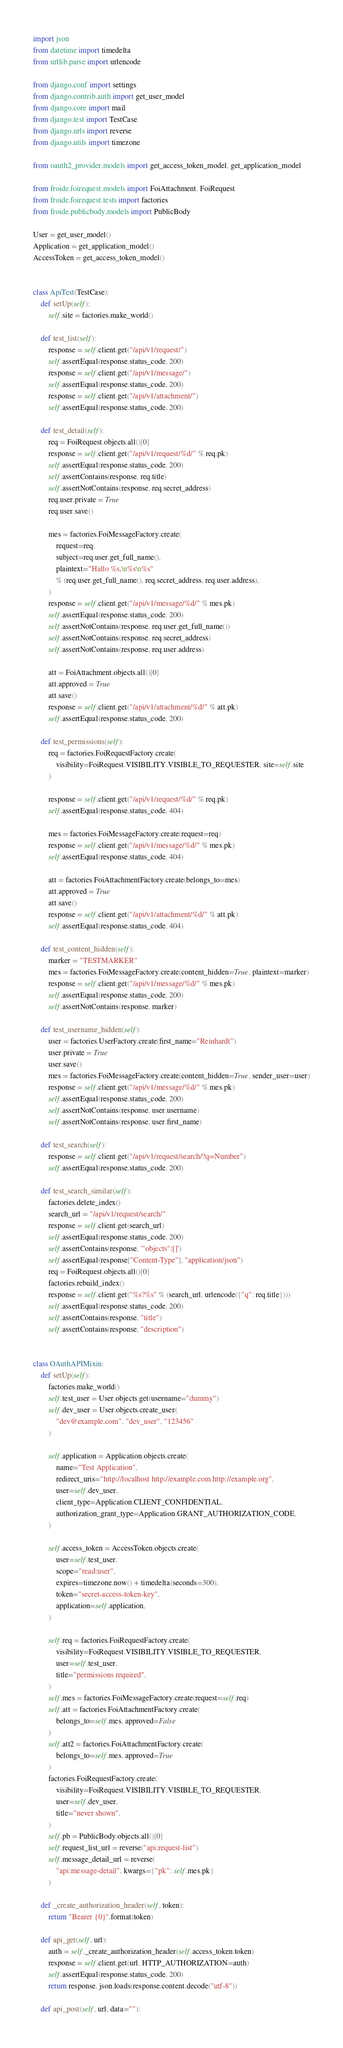Convert code to text. <code><loc_0><loc_0><loc_500><loc_500><_Python_>import json
from datetime import timedelta
from urllib.parse import urlencode

from django.conf import settings
from django.contrib.auth import get_user_model
from django.core import mail
from django.test import TestCase
from django.urls import reverse
from django.utils import timezone

from oauth2_provider.models import get_access_token_model, get_application_model

from froide.foirequest.models import FoiAttachment, FoiRequest
from froide.foirequest.tests import factories
from froide.publicbody.models import PublicBody

User = get_user_model()
Application = get_application_model()
AccessToken = get_access_token_model()


class ApiTest(TestCase):
    def setUp(self):
        self.site = factories.make_world()

    def test_list(self):
        response = self.client.get("/api/v1/request/")
        self.assertEqual(response.status_code, 200)
        response = self.client.get("/api/v1/message/")
        self.assertEqual(response.status_code, 200)
        response = self.client.get("/api/v1/attachment/")
        self.assertEqual(response.status_code, 200)

    def test_detail(self):
        req = FoiRequest.objects.all()[0]
        response = self.client.get("/api/v1/request/%d/" % req.pk)
        self.assertEqual(response.status_code, 200)
        self.assertContains(response, req.title)
        self.assertNotContains(response, req.secret_address)
        req.user.private = True
        req.user.save()

        mes = factories.FoiMessageFactory.create(
            request=req,
            subject=req.user.get_full_name(),
            plaintext="Hallo %s,\n%s\n%s"
            % (req.user.get_full_name(), req.secret_address, req.user.address),
        )
        response = self.client.get("/api/v1/message/%d/" % mes.pk)
        self.assertEqual(response.status_code, 200)
        self.assertNotContains(response, req.user.get_full_name())
        self.assertNotContains(response, req.secret_address)
        self.assertNotContains(response, req.user.address)

        att = FoiAttachment.objects.all()[0]
        att.approved = True
        att.save()
        response = self.client.get("/api/v1/attachment/%d/" % att.pk)
        self.assertEqual(response.status_code, 200)

    def test_permissions(self):
        req = factories.FoiRequestFactory.create(
            visibility=FoiRequest.VISIBILITY.VISIBLE_TO_REQUESTER, site=self.site
        )

        response = self.client.get("/api/v1/request/%d/" % req.pk)
        self.assertEqual(response.status_code, 404)

        mes = factories.FoiMessageFactory.create(request=req)
        response = self.client.get("/api/v1/message/%d/" % mes.pk)
        self.assertEqual(response.status_code, 404)

        att = factories.FoiAttachmentFactory.create(belongs_to=mes)
        att.approved = True
        att.save()
        response = self.client.get("/api/v1/attachment/%d/" % att.pk)
        self.assertEqual(response.status_code, 404)

    def test_content_hidden(self):
        marker = "TESTMARKER"
        mes = factories.FoiMessageFactory.create(content_hidden=True, plaintext=marker)
        response = self.client.get("/api/v1/message/%d/" % mes.pk)
        self.assertEqual(response.status_code, 200)
        self.assertNotContains(response, marker)

    def test_username_hidden(self):
        user = factories.UserFactory.create(first_name="Reinhardt")
        user.private = True
        user.save()
        mes = factories.FoiMessageFactory.create(content_hidden=True, sender_user=user)
        response = self.client.get("/api/v1/message/%d/" % mes.pk)
        self.assertEqual(response.status_code, 200)
        self.assertNotContains(response, user.username)
        self.assertNotContains(response, user.first_name)

    def test_search(self):
        response = self.client.get("/api/v1/request/search/?q=Number")
        self.assertEqual(response.status_code, 200)

    def test_search_similar(self):
        factories.delete_index()
        search_url = "/api/v1/request/search/"
        response = self.client.get(search_url)
        self.assertEqual(response.status_code, 200)
        self.assertContains(response, '"objects":[]')
        self.assertEqual(response["Content-Type"], "application/json")
        req = FoiRequest.objects.all()[0]
        factories.rebuild_index()
        response = self.client.get("%s?%s" % (search_url, urlencode({"q": req.title})))
        self.assertEqual(response.status_code, 200)
        self.assertContains(response, "title")
        self.assertContains(response, "description")


class OAuthAPIMixin:
    def setUp(self):
        factories.make_world()
        self.test_user = User.objects.get(username="dummy")
        self.dev_user = User.objects.create_user(
            "dev@example.com", "dev_user", "123456"
        )

        self.application = Application.objects.create(
            name="Test Application",
            redirect_uris="http://localhost http://example.com http://example.org",
            user=self.dev_user,
            client_type=Application.CLIENT_CONFIDENTIAL,
            authorization_grant_type=Application.GRANT_AUTHORIZATION_CODE,
        )

        self.access_token = AccessToken.objects.create(
            user=self.test_user,
            scope="read:user",
            expires=timezone.now() + timedelta(seconds=300),
            token="secret-access-token-key",
            application=self.application,
        )

        self.req = factories.FoiRequestFactory.create(
            visibility=FoiRequest.VISIBILITY.VISIBLE_TO_REQUESTER,
            user=self.test_user,
            title="permissions required",
        )
        self.mes = factories.FoiMessageFactory.create(request=self.req)
        self.att = factories.FoiAttachmentFactory.create(
            belongs_to=self.mes, approved=False
        )
        self.att2 = factories.FoiAttachmentFactory.create(
            belongs_to=self.mes, approved=True
        )
        factories.FoiRequestFactory.create(
            visibility=FoiRequest.VISIBILITY.VISIBLE_TO_REQUESTER,
            user=self.dev_user,
            title="never shown",
        )
        self.pb = PublicBody.objects.all()[0]
        self.request_list_url = reverse("api:request-list")
        self.message_detail_url = reverse(
            "api:message-detail", kwargs={"pk": self.mes.pk}
        )

    def _create_authorization_header(self, token):
        return "Bearer {0}".format(token)

    def api_get(self, url):
        auth = self._create_authorization_header(self.access_token.token)
        response = self.client.get(url, HTTP_AUTHORIZATION=auth)
        self.assertEqual(response.status_code, 200)
        return response, json.loads(response.content.decode("utf-8"))

    def api_post(self, url, data=""):</code> 